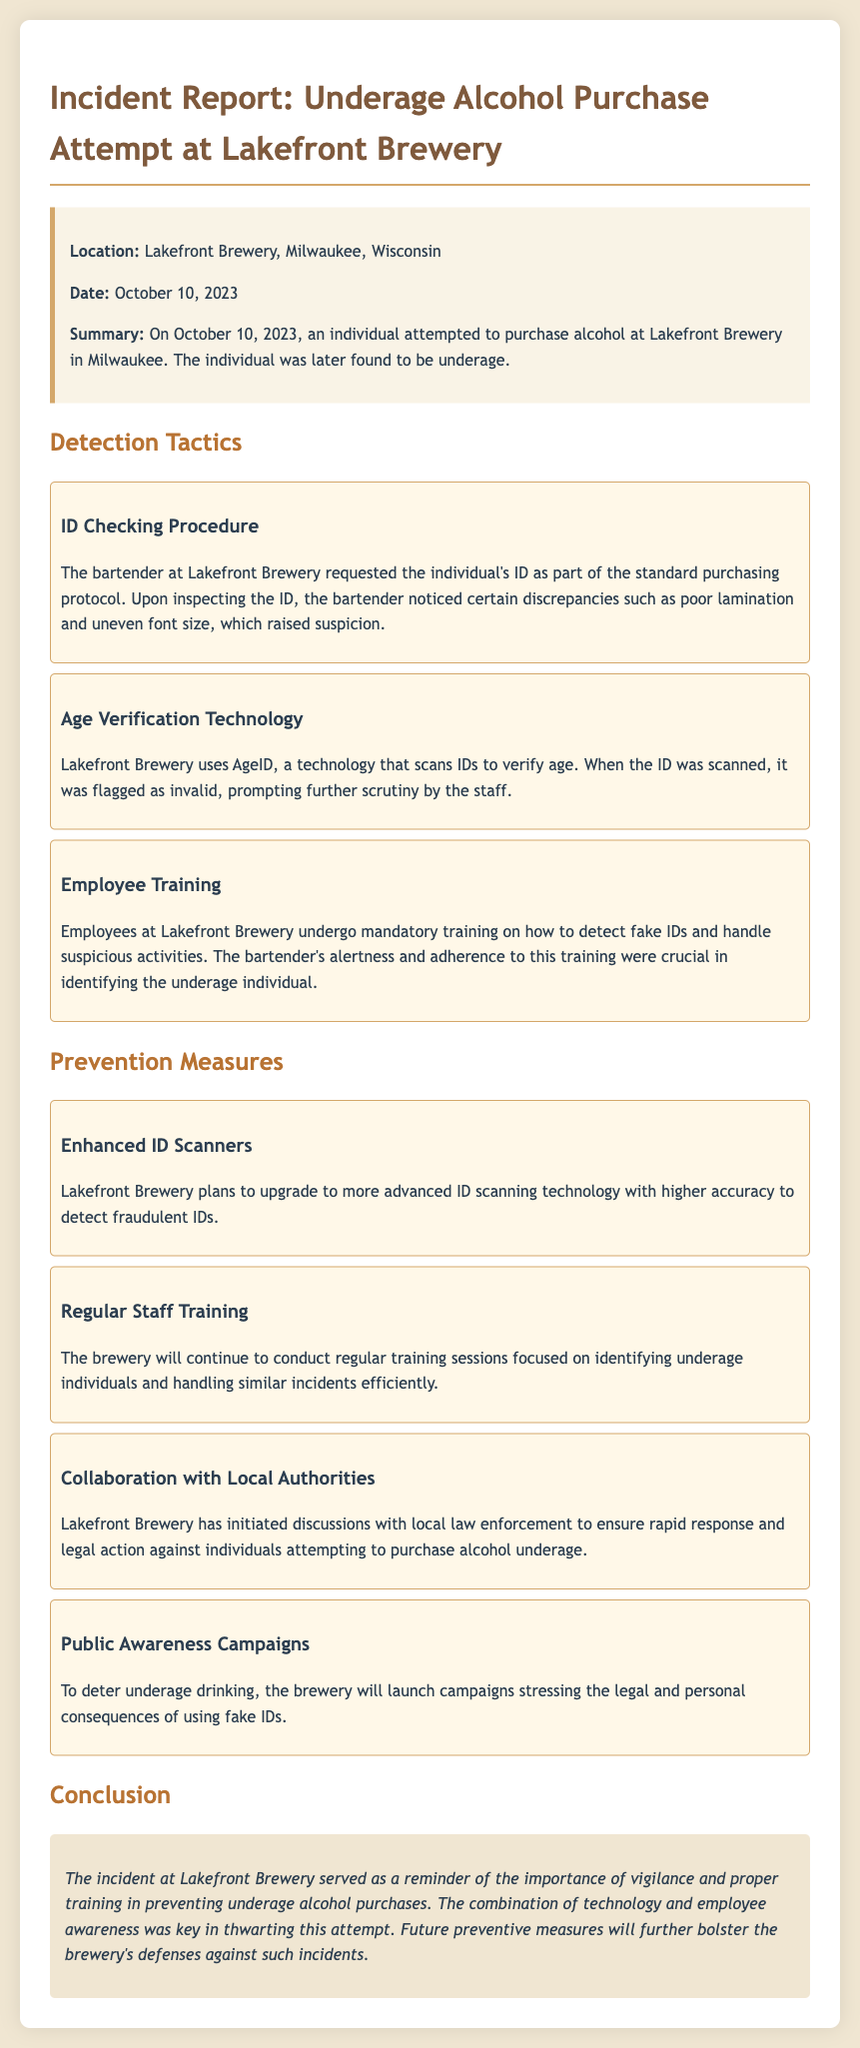What is the location of the incident? The location is specified in the incident report as the place where the event occurred, which is Lakefront Brewery, Milwaukee, Wisconsin.
Answer: Lakefront Brewery, Milwaukee, Wisconsin What date did the incident occur? The date of the incident is clearly stated in the incident report under the date section.
Answer: October 10, 2023 What identification procedure was used by the bartender? The report details the standard purchasing protocol, which involves requesting the individual's ID.
Answer: ID Checking Procedure What technology was utilized for age verification? The report mentions a specific type of technology used for verifying age, which helps in identifying underage attempts.
Answer: AgeID What was flagged as invalid during the ID check? The report notes that when the ID was scanned, it was flagged, leading to further scrutiny.
Answer: ID How does Lakefront Brewery plan to enhance their detection capabilities? The report outlines plans for upgrading technology to a more advanced version for better accuracy in detecting fake IDs.
Answer: Enhanced ID Scanners What training do employees receive? The report explains that employees undergo training focused on detecting fake IDs and handling suspicious activities.
Answer: Employee Training What strategy is Lakefront Brewery adopting with local authorities? The report mentions that the brewery is discussing with law enforcement to ensure quick responses to incidents.
Answer: Collaboration with Local Authorities What is the main message of the public awareness campaigns? The report explains that the campaigns will focus on the consequences of using fake IDs to deter underage drinking.
Answer: Legal and personal consequences What is the overall conclusion of the incident report? The report summarizes the overall importance of vigilance and training in preventing such occurrences at the brewery.
Answer: Importance of vigilance and proper training 